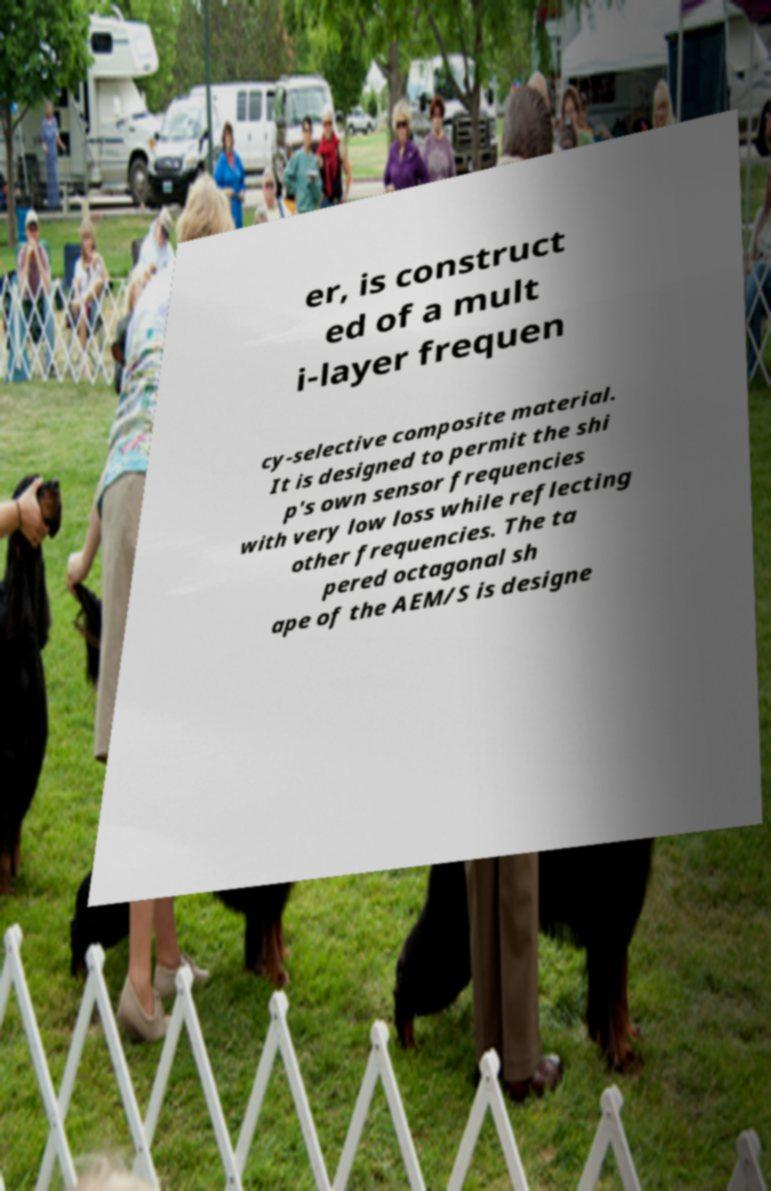For documentation purposes, I need the text within this image transcribed. Could you provide that? er, is construct ed of a mult i-layer frequen cy-selective composite material. It is designed to permit the shi p's own sensor frequencies with very low loss while reflecting other frequencies. The ta pered octagonal sh ape of the AEM/S is designe 